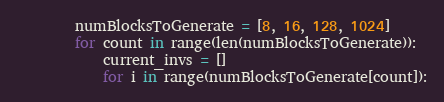<code> <loc_0><loc_0><loc_500><loc_500><_Python_>
        numBlocksToGenerate = [8, 16, 128, 1024]
        for count in range(len(numBlocksToGenerate)):
            current_invs = []
            for i in range(numBlocksToGenerate[count]):</code> 